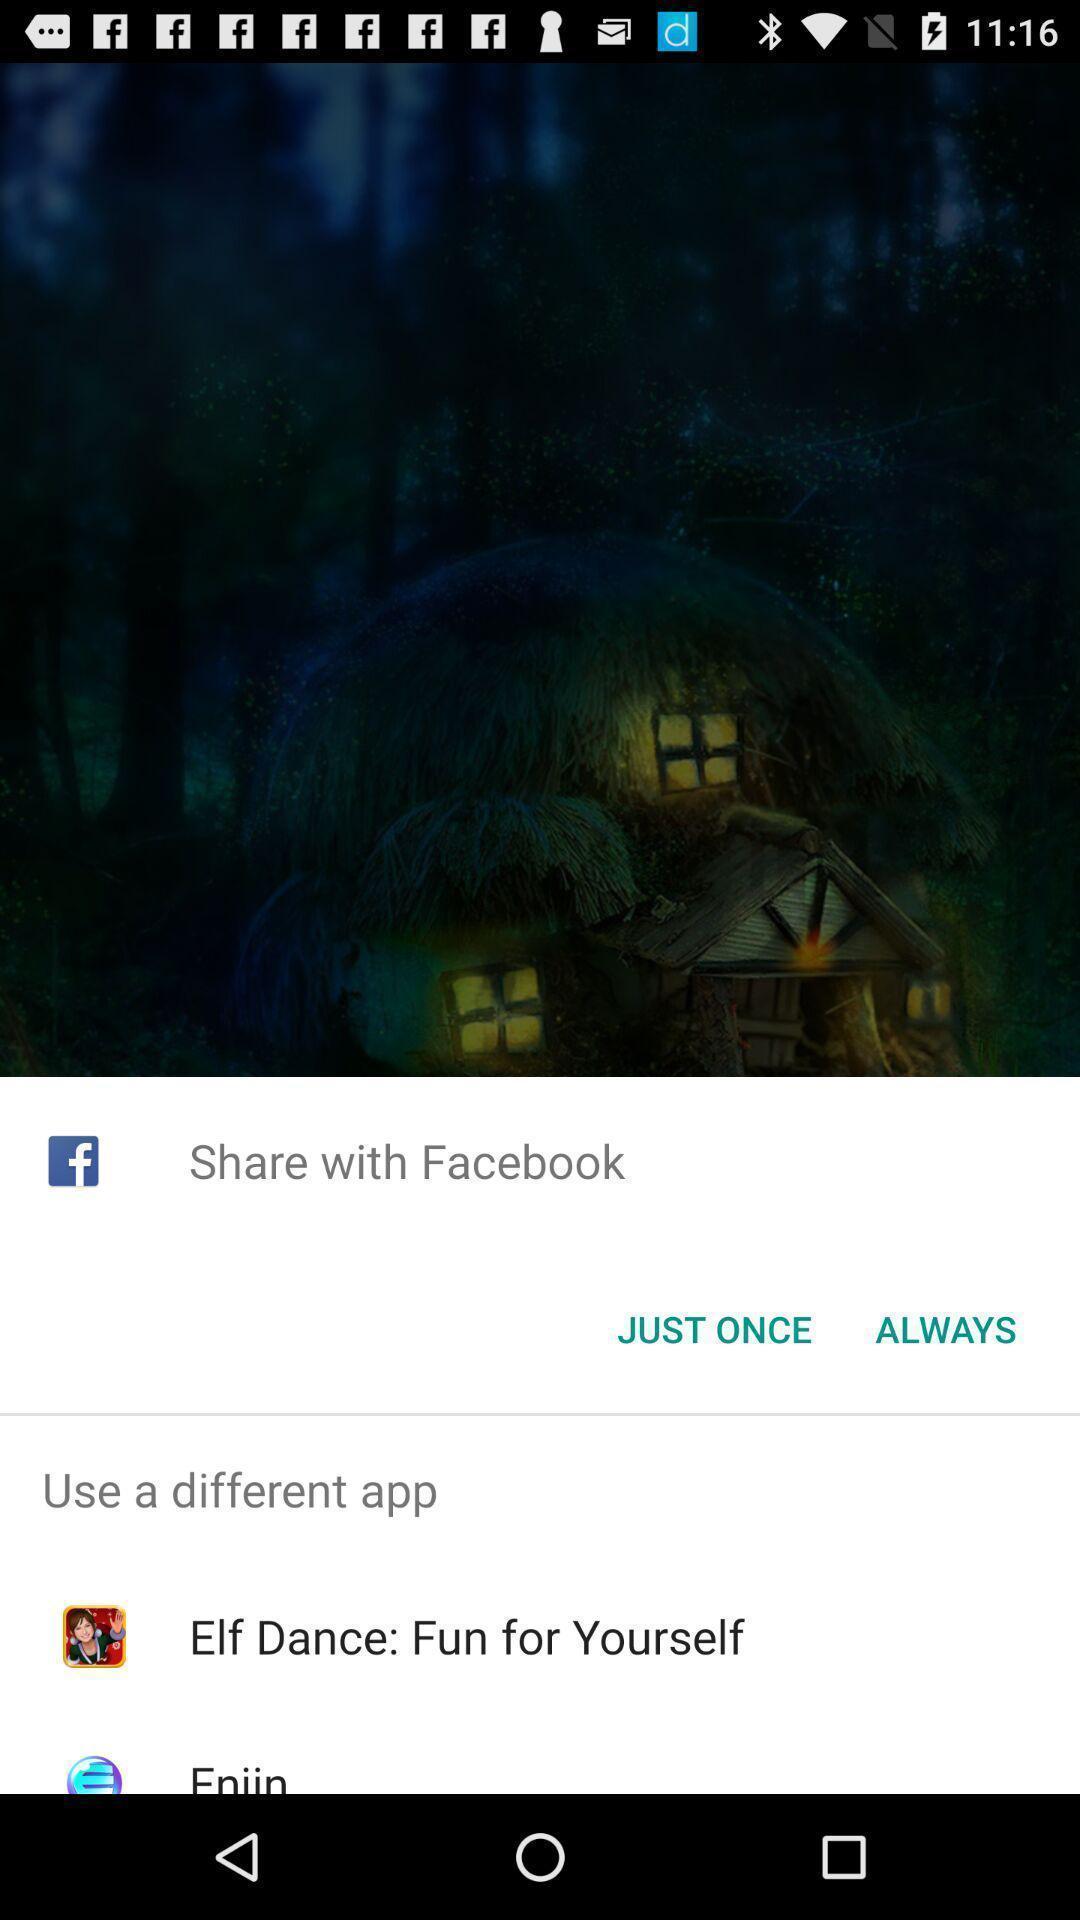Give me a summary of this screen capture. Share with options page of an entertainment app. 